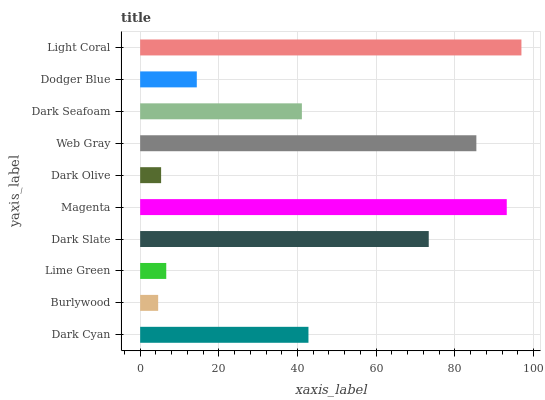Is Burlywood the minimum?
Answer yes or no. Yes. Is Light Coral the maximum?
Answer yes or no. Yes. Is Lime Green the minimum?
Answer yes or no. No. Is Lime Green the maximum?
Answer yes or no. No. Is Lime Green greater than Burlywood?
Answer yes or no. Yes. Is Burlywood less than Lime Green?
Answer yes or no. Yes. Is Burlywood greater than Lime Green?
Answer yes or no. No. Is Lime Green less than Burlywood?
Answer yes or no. No. Is Dark Cyan the high median?
Answer yes or no. Yes. Is Dark Seafoam the low median?
Answer yes or no. Yes. Is Web Gray the high median?
Answer yes or no. No. Is Web Gray the low median?
Answer yes or no. No. 